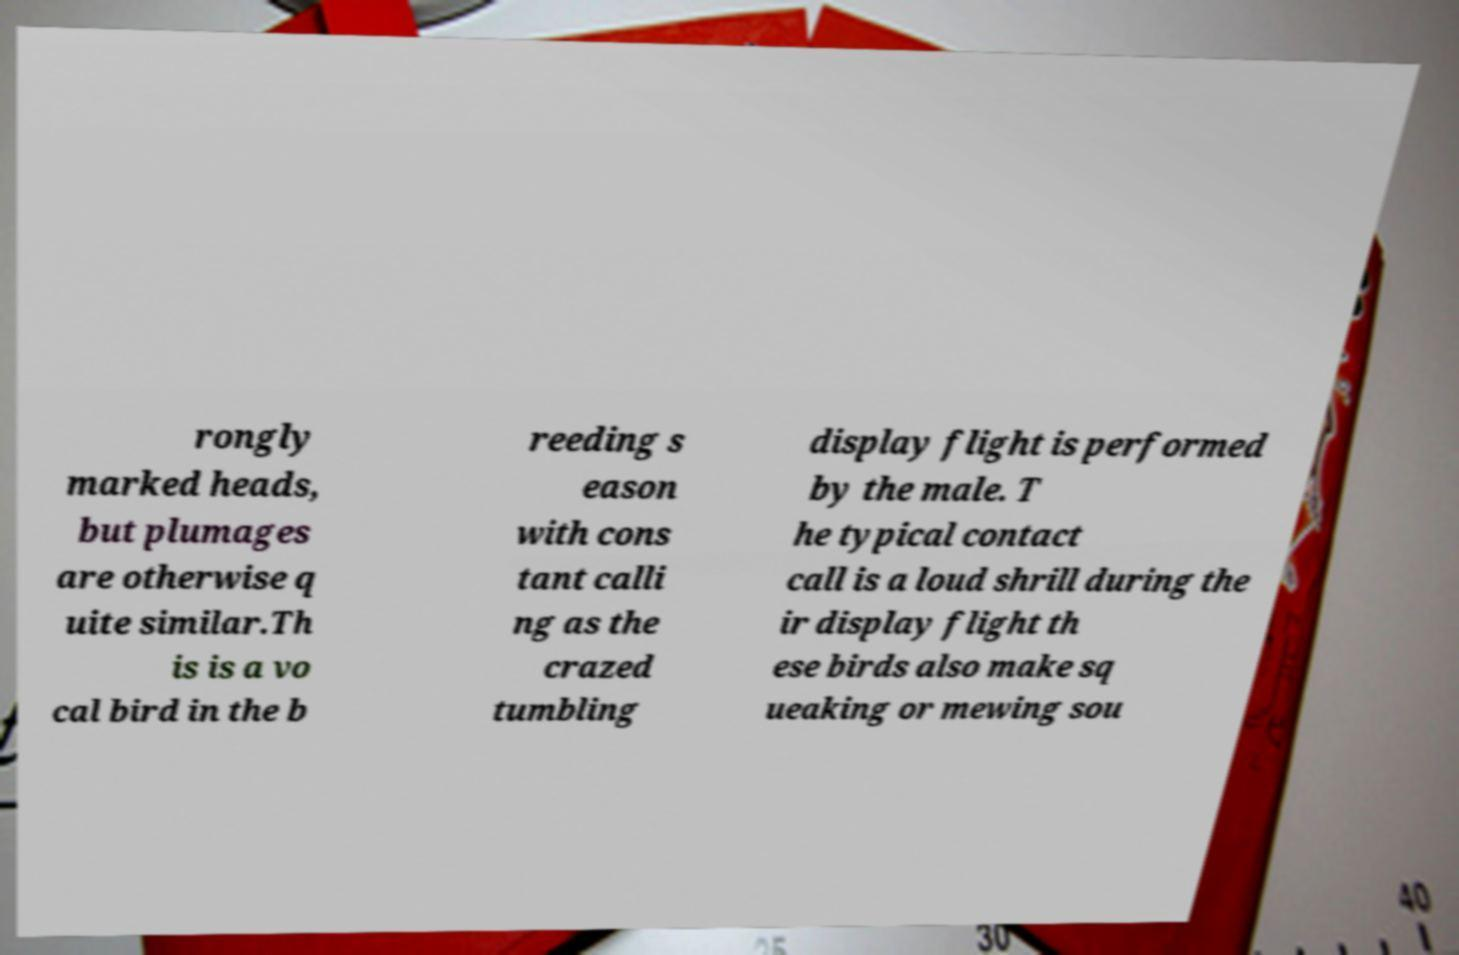For documentation purposes, I need the text within this image transcribed. Could you provide that? rongly marked heads, but plumages are otherwise q uite similar.Th is is a vo cal bird in the b reeding s eason with cons tant calli ng as the crazed tumbling display flight is performed by the male. T he typical contact call is a loud shrill during the ir display flight th ese birds also make sq ueaking or mewing sou 